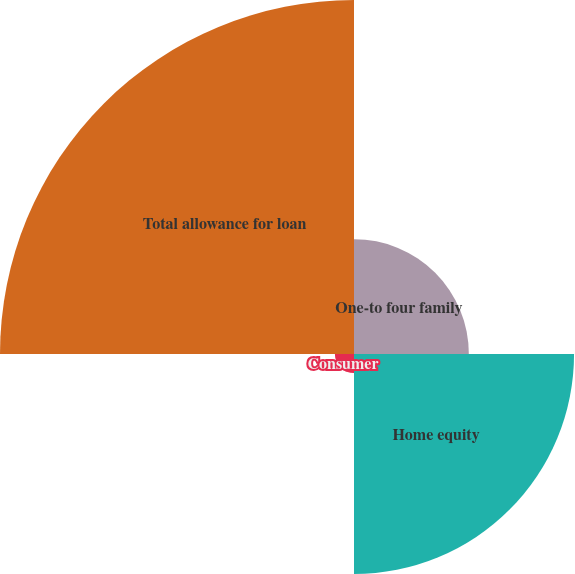<chart> <loc_0><loc_0><loc_500><loc_500><pie_chart><fcel>One-to four family<fcel>Home equity<fcel>Consumer<fcel>Total allowance for loan<nl><fcel>16.22%<fcel>31.08%<fcel>2.7%<fcel>50.0%<nl></chart> 